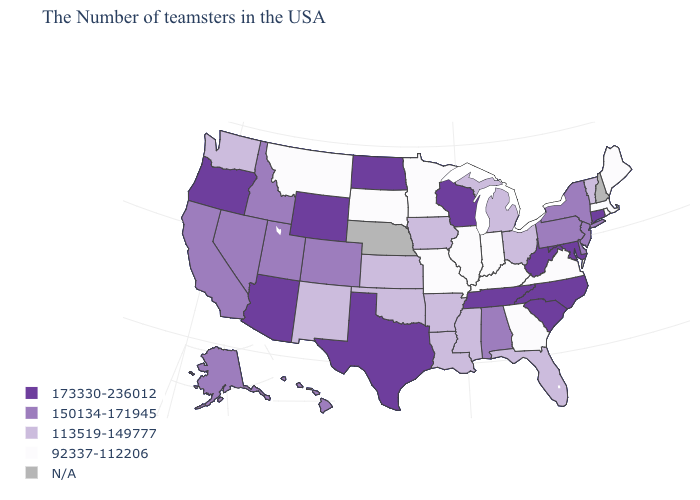What is the highest value in the USA?
Give a very brief answer. 173330-236012. How many symbols are there in the legend?
Write a very short answer. 5. Name the states that have a value in the range 173330-236012?
Keep it brief. Connecticut, Maryland, North Carolina, South Carolina, West Virginia, Tennessee, Wisconsin, Texas, North Dakota, Wyoming, Arizona, Oregon. Name the states that have a value in the range 92337-112206?
Answer briefly. Maine, Massachusetts, Rhode Island, Virginia, Georgia, Kentucky, Indiana, Illinois, Missouri, Minnesota, South Dakota, Montana. What is the value of New Jersey?
Be succinct. 150134-171945. Name the states that have a value in the range N/A?
Keep it brief. New Hampshire, Nebraska. Name the states that have a value in the range 150134-171945?
Be succinct. New York, New Jersey, Delaware, Pennsylvania, Alabama, Colorado, Utah, Idaho, Nevada, California, Alaska, Hawaii. Which states have the lowest value in the West?
Write a very short answer. Montana. Which states have the highest value in the USA?
Concise answer only. Connecticut, Maryland, North Carolina, South Carolina, West Virginia, Tennessee, Wisconsin, Texas, North Dakota, Wyoming, Arizona, Oregon. What is the value of Rhode Island?
Quick response, please. 92337-112206. What is the value of Georgia?
Answer briefly. 92337-112206. Name the states that have a value in the range N/A?
Give a very brief answer. New Hampshire, Nebraska. Which states have the lowest value in the USA?
Quick response, please. Maine, Massachusetts, Rhode Island, Virginia, Georgia, Kentucky, Indiana, Illinois, Missouri, Minnesota, South Dakota, Montana. Name the states that have a value in the range 113519-149777?
Give a very brief answer. Vermont, Ohio, Florida, Michigan, Mississippi, Louisiana, Arkansas, Iowa, Kansas, Oklahoma, New Mexico, Washington. Which states have the highest value in the USA?
Short answer required. Connecticut, Maryland, North Carolina, South Carolina, West Virginia, Tennessee, Wisconsin, Texas, North Dakota, Wyoming, Arizona, Oregon. 